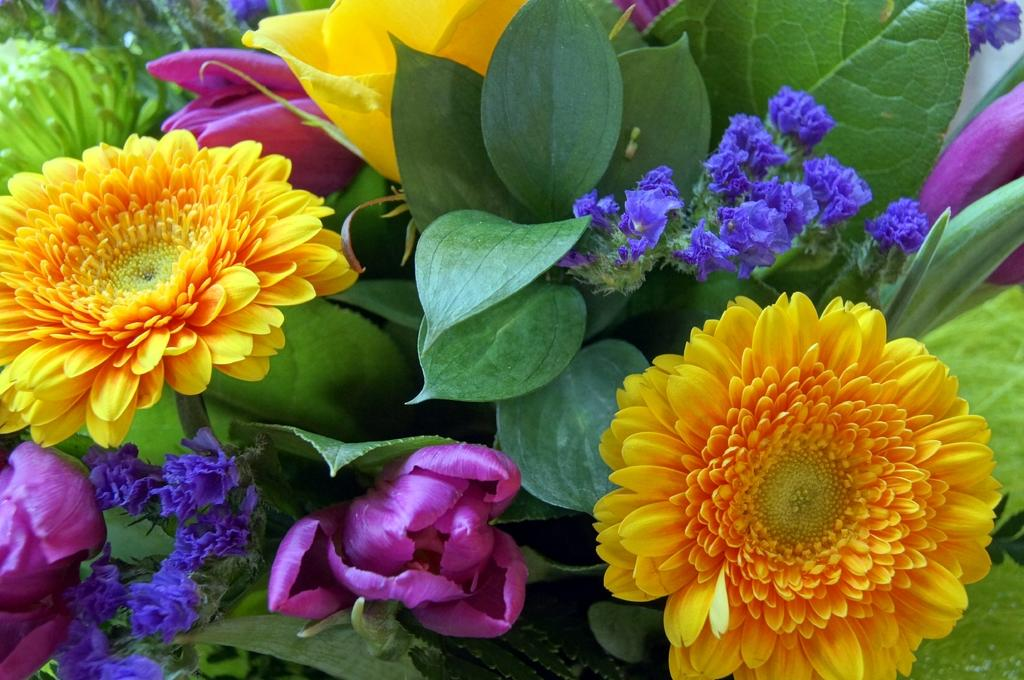What is present in the image? There is a plant in the image. What can be observed about the plant? The plant has flowers. What colors are the flowers? The flowers are in yellow, purple, and blue colors. What time of day is depicted in the image? The provided facts do not mention the time of day, so it cannot be determined from the image. What type of chalk is being used to draw on the plant? There is no chalk present in the image, and the plant is not being drawn on. 